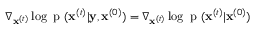Convert formula to latex. <formula><loc_0><loc_0><loc_500><loc_500>\nabla _ { x ^ { ( t ) } } \log { p ( x ^ { ( t ) } | y } , x ^ { ( 0 ) } ) = \nabla _ { x ^ { ( t ) } } \log { p ( x ^ { ( t ) } | x ^ { ( 0 ) } ) }</formula> 